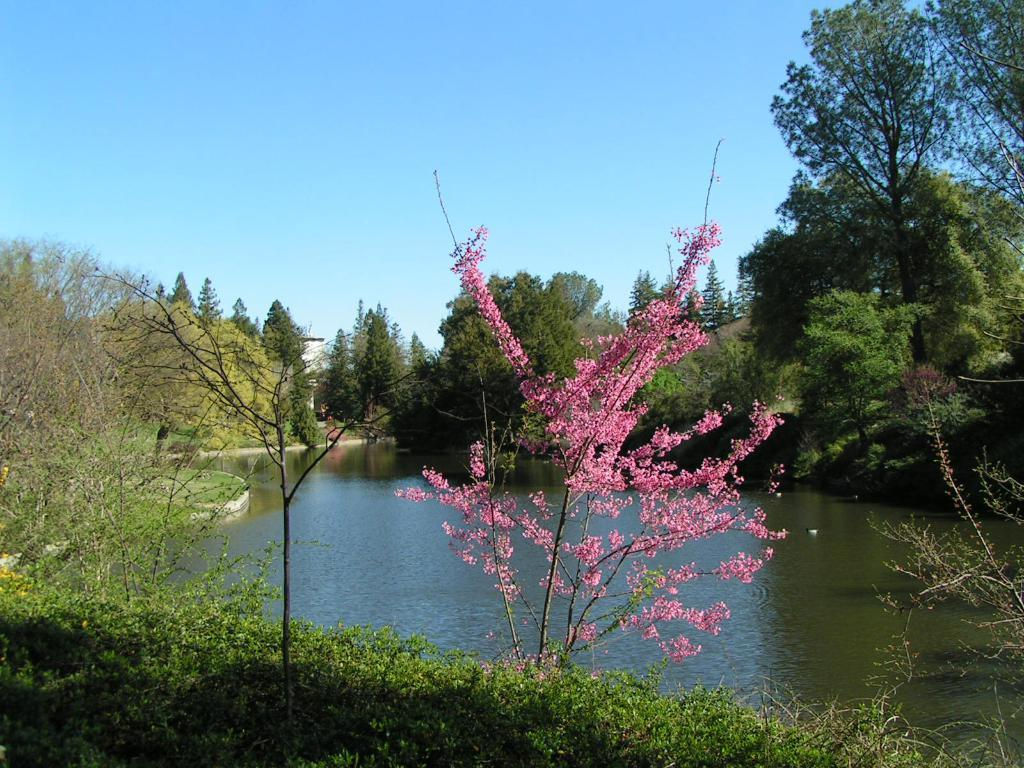What color is the plant on the ground in the image? The plant on the ground is pink. What else can be seen in the image besides the pink plant? There are other plants and a pond visible in the image. What is in the background of the image? There are trees and the sky visible in the background of the image. How many vests are hanging on the trees in the image? There are no vests present in the image; it features plants, a pond, trees, and the sky. What is the fifth element in the image? The image contains five main elements: the pink plant, other plants, the pond, trees, and the sky. There is no "fifth" element as they are all part of the same image. 